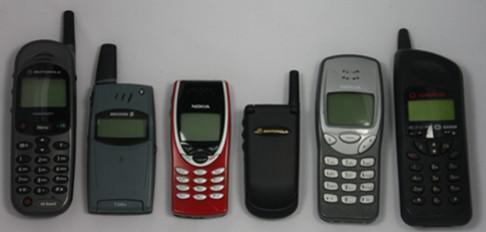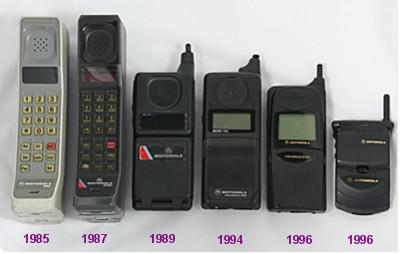The first image is the image on the left, the second image is the image on the right. Considering the images on both sides, is "At least one flip phone is visible in the right image." valid? Answer yes or no. Yes. The first image is the image on the left, the second image is the image on the right. Assess this claim about the two images: "Three or fewer phones are visible.". Correct or not? Answer yes or no. No. 